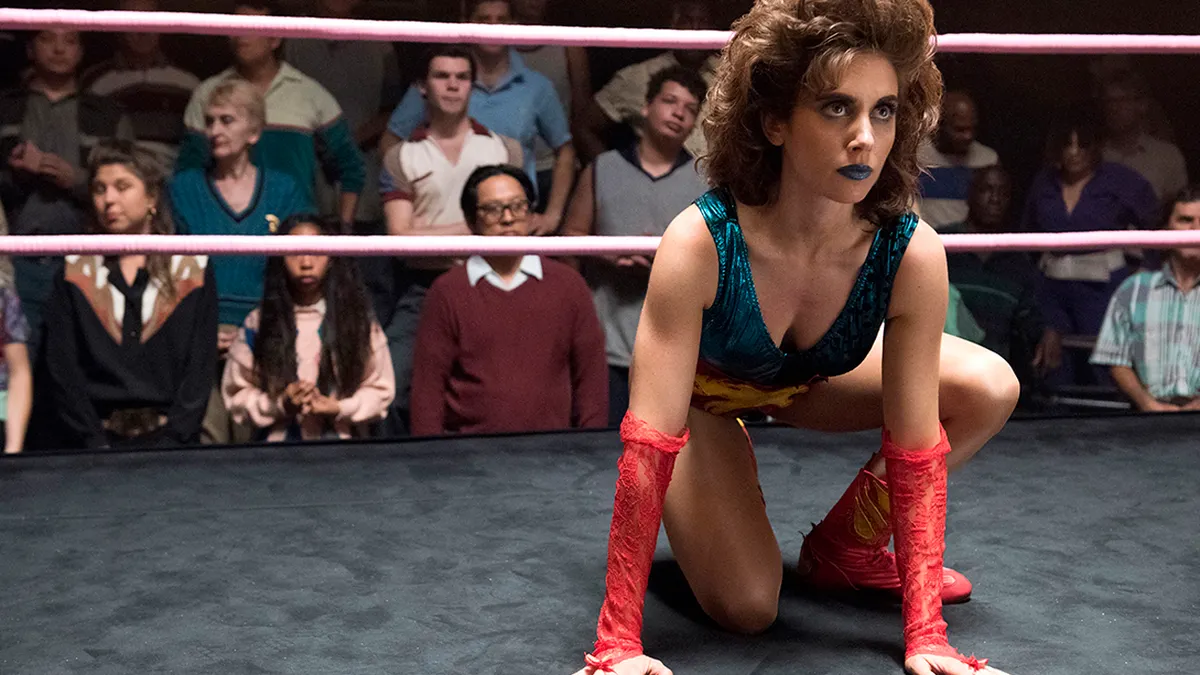What does the wrestler's stance indicate about her possible tactics? The wrestler's low, crouched stance suggests that she's preparing to either spring into action or defend against an opponent's move. This position allows for quick movements and indicates a strategic approach to the match, showcasing readiness to engage with agility and strength. 